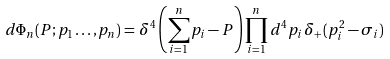Convert formula to latex. <formula><loc_0><loc_0><loc_500><loc_500>d \Phi _ { n } ( P ; p _ { 1 } \dots , p _ { n } ) = \, \delta ^ { 4 } \left ( \sum _ { i = 1 } ^ { n } p _ { i } - P \right ) \prod _ { i = 1 } ^ { n } d ^ { 4 } p _ { i } \, \delta _ { + } ( p _ { i } ^ { 2 } - \sigma _ { i } )</formula> 